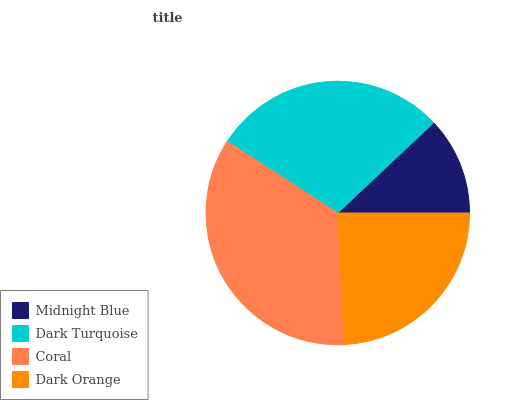Is Midnight Blue the minimum?
Answer yes or no. Yes. Is Coral the maximum?
Answer yes or no. Yes. Is Dark Turquoise the minimum?
Answer yes or no. No. Is Dark Turquoise the maximum?
Answer yes or no. No. Is Dark Turquoise greater than Midnight Blue?
Answer yes or no. Yes. Is Midnight Blue less than Dark Turquoise?
Answer yes or no. Yes. Is Midnight Blue greater than Dark Turquoise?
Answer yes or no. No. Is Dark Turquoise less than Midnight Blue?
Answer yes or no. No. Is Dark Turquoise the high median?
Answer yes or no. Yes. Is Dark Orange the low median?
Answer yes or no. Yes. Is Dark Orange the high median?
Answer yes or no. No. Is Midnight Blue the low median?
Answer yes or no. No. 